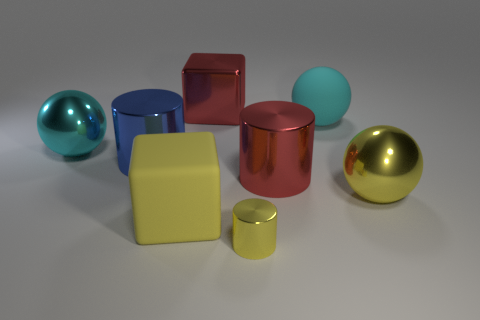There is a blue metallic thing that is the same shape as the tiny yellow metallic thing; what is its size?
Your answer should be very brief. Large. What number of other objects are the same material as the large yellow block?
Offer a terse response. 1. What is the material of the tiny yellow object?
Your response must be concise. Metal. There is a metallic cylinder to the right of the tiny shiny object; does it have the same color as the big metallic ball left of the yellow cube?
Make the answer very short. No. Are there more large yellow rubber things that are behind the big blue metallic object than gray rubber cylinders?
Make the answer very short. No. How many other things are there of the same color as the tiny shiny cylinder?
Give a very brief answer. 2. Is the size of the red thing that is in front of the red shiny block the same as the large blue metal thing?
Give a very brief answer. Yes. Is there a red metallic cylinder that has the same size as the yellow matte cube?
Provide a succinct answer. Yes. There is a metal ball right of the red metal cylinder; what is its color?
Offer a very short reply. Yellow. There is a yellow thing that is both on the right side of the large yellow cube and to the left of the large cyan rubber object; what shape is it?
Ensure brevity in your answer.  Cylinder. 